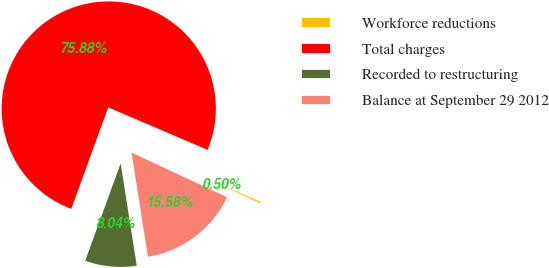Convert chart. <chart><loc_0><loc_0><loc_500><loc_500><pie_chart><fcel>Workforce reductions<fcel>Total charges<fcel>Recorded to restructuring<fcel>Balance at September 29 2012<nl><fcel>0.5%<fcel>75.89%<fcel>8.04%<fcel>15.58%<nl></chart> 